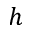<formula> <loc_0><loc_0><loc_500><loc_500>h</formula> 